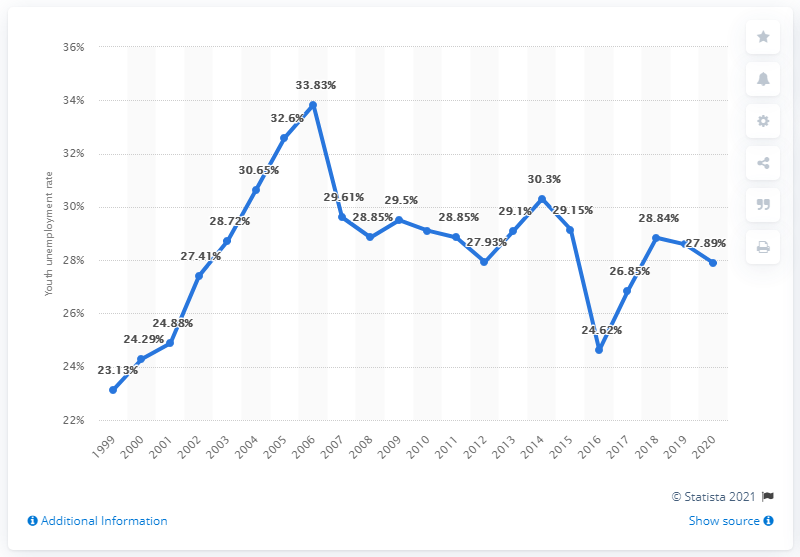List a handful of essential elements in this visual. In 2020, Saudi Arabia's youth unemployment rate was 27.89%. 